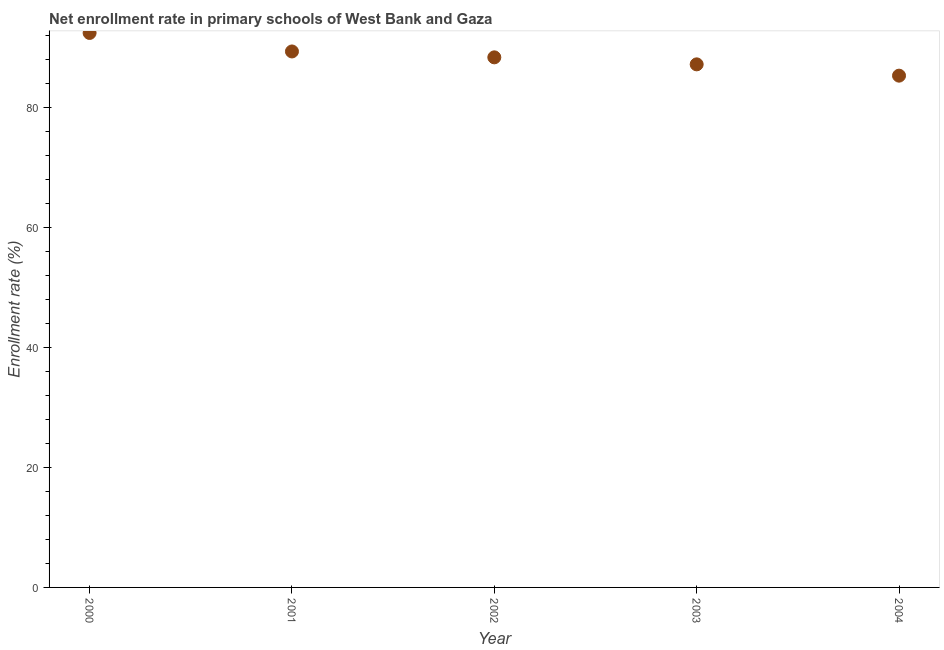What is the net enrollment rate in primary schools in 2002?
Offer a very short reply. 88.42. Across all years, what is the maximum net enrollment rate in primary schools?
Your response must be concise. 92.48. Across all years, what is the minimum net enrollment rate in primary schools?
Your answer should be compact. 85.36. What is the sum of the net enrollment rate in primary schools?
Give a very brief answer. 442.91. What is the difference between the net enrollment rate in primary schools in 2000 and 2002?
Keep it short and to the point. 4.07. What is the average net enrollment rate in primary schools per year?
Keep it short and to the point. 88.58. What is the median net enrollment rate in primary schools?
Provide a succinct answer. 88.42. Do a majority of the years between 2000 and 2004 (inclusive) have net enrollment rate in primary schools greater than 20 %?
Give a very brief answer. Yes. What is the ratio of the net enrollment rate in primary schools in 2001 to that in 2003?
Provide a succinct answer. 1.02. Is the difference between the net enrollment rate in primary schools in 2001 and 2004 greater than the difference between any two years?
Provide a short and direct response. No. What is the difference between the highest and the second highest net enrollment rate in primary schools?
Provide a short and direct response. 3.08. Is the sum of the net enrollment rate in primary schools in 2000 and 2004 greater than the maximum net enrollment rate in primary schools across all years?
Your answer should be very brief. Yes. What is the difference between the highest and the lowest net enrollment rate in primary schools?
Provide a short and direct response. 7.12. In how many years, is the net enrollment rate in primary schools greater than the average net enrollment rate in primary schools taken over all years?
Give a very brief answer. 2. Does the net enrollment rate in primary schools monotonically increase over the years?
Provide a short and direct response. No. How many dotlines are there?
Make the answer very short. 1. How many years are there in the graph?
Your answer should be very brief. 5. Are the values on the major ticks of Y-axis written in scientific E-notation?
Ensure brevity in your answer.  No. What is the title of the graph?
Keep it short and to the point. Net enrollment rate in primary schools of West Bank and Gaza. What is the label or title of the X-axis?
Offer a very short reply. Year. What is the label or title of the Y-axis?
Offer a terse response. Enrollment rate (%). What is the Enrollment rate (%) in 2000?
Provide a short and direct response. 92.48. What is the Enrollment rate (%) in 2001?
Give a very brief answer. 89.4. What is the Enrollment rate (%) in 2002?
Keep it short and to the point. 88.42. What is the Enrollment rate (%) in 2003?
Keep it short and to the point. 87.25. What is the Enrollment rate (%) in 2004?
Your answer should be compact. 85.36. What is the difference between the Enrollment rate (%) in 2000 and 2001?
Your response must be concise. 3.08. What is the difference between the Enrollment rate (%) in 2000 and 2002?
Provide a succinct answer. 4.07. What is the difference between the Enrollment rate (%) in 2000 and 2003?
Ensure brevity in your answer.  5.24. What is the difference between the Enrollment rate (%) in 2000 and 2004?
Make the answer very short. 7.12. What is the difference between the Enrollment rate (%) in 2001 and 2002?
Offer a terse response. 0.98. What is the difference between the Enrollment rate (%) in 2001 and 2003?
Provide a short and direct response. 2.15. What is the difference between the Enrollment rate (%) in 2001 and 2004?
Your answer should be very brief. 4.04. What is the difference between the Enrollment rate (%) in 2002 and 2003?
Offer a terse response. 1.17. What is the difference between the Enrollment rate (%) in 2002 and 2004?
Give a very brief answer. 3.05. What is the difference between the Enrollment rate (%) in 2003 and 2004?
Provide a short and direct response. 1.88. What is the ratio of the Enrollment rate (%) in 2000 to that in 2001?
Offer a very short reply. 1.03. What is the ratio of the Enrollment rate (%) in 2000 to that in 2002?
Offer a very short reply. 1.05. What is the ratio of the Enrollment rate (%) in 2000 to that in 2003?
Make the answer very short. 1.06. What is the ratio of the Enrollment rate (%) in 2000 to that in 2004?
Keep it short and to the point. 1.08. What is the ratio of the Enrollment rate (%) in 2001 to that in 2003?
Your response must be concise. 1.02. What is the ratio of the Enrollment rate (%) in 2001 to that in 2004?
Your response must be concise. 1.05. What is the ratio of the Enrollment rate (%) in 2002 to that in 2004?
Your answer should be very brief. 1.04. What is the ratio of the Enrollment rate (%) in 2003 to that in 2004?
Your answer should be compact. 1.02. 